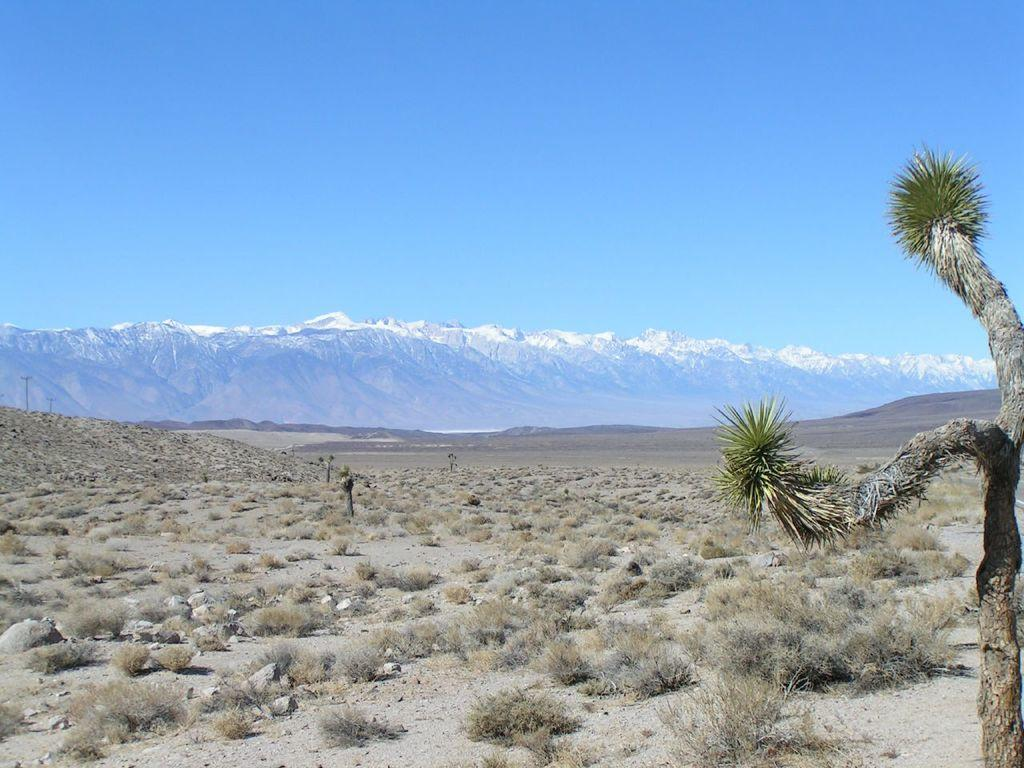What type of vegetation is on the ground in the image? There are plants on the ground in the image. Where is the tree located in the image? The tree is on the right side of the image. What can be seen in the background of the image? There is a mountain and the sky visible in the background of the image. What type of cherry is hanging from the tree in the image? There is no cherry present in the image; it only features a tree and plants on the ground. How does the lamp illuminate the mountain in the image? There is no lamp present in the image; it only features a tree, plants, and a mountain in the background. 